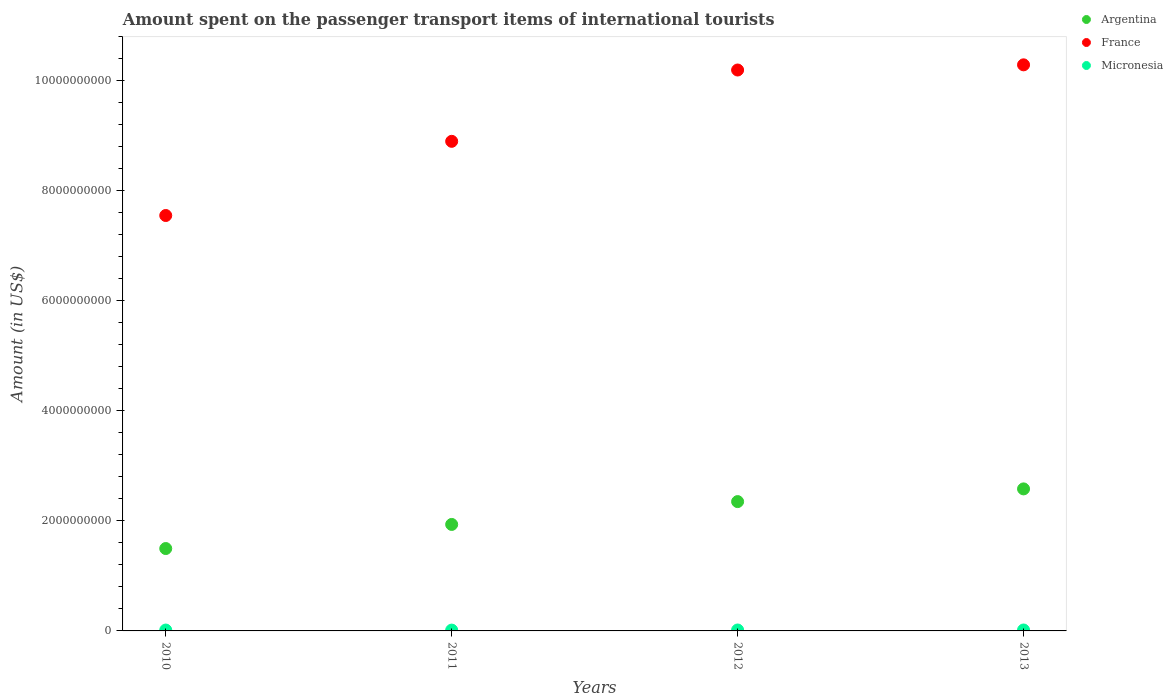What is the amount spent on the passenger transport items of international tourists in Micronesia in 2012?
Offer a terse response. 1.70e+07. Across all years, what is the maximum amount spent on the passenger transport items of international tourists in Micronesia?
Offer a very short reply. 1.70e+07. Across all years, what is the minimum amount spent on the passenger transport items of international tourists in France?
Your answer should be compact. 7.55e+09. In which year was the amount spent on the passenger transport items of international tourists in France maximum?
Provide a short and direct response. 2013. In which year was the amount spent on the passenger transport items of international tourists in France minimum?
Ensure brevity in your answer.  2010. What is the total amount spent on the passenger transport items of international tourists in France in the graph?
Offer a terse response. 3.69e+1. What is the difference between the amount spent on the passenger transport items of international tourists in France in 2013 and the amount spent on the passenger transport items of international tourists in Micronesia in 2012?
Offer a very short reply. 1.03e+1. What is the average amount spent on the passenger transport items of international tourists in France per year?
Provide a short and direct response. 9.23e+09. In the year 2012, what is the difference between the amount spent on the passenger transport items of international tourists in Micronesia and amount spent on the passenger transport items of international tourists in Argentina?
Provide a short and direct response. -2.33e+09. In how many years, is the amount spent on the passenger transport items of international tourists in Argentina greater than 3200000000 US$?
Provide a succinct answer. 0. What is the ratio of the amount spent on the passenger transport items of international tourists in France in 2010 to that in 2013?
Your answer should be very brief. 0.73. Is the difference between the amount spent on the passenger transport items of international tourists in Micronesia in 2010 and 2012 greater than the difference between the amount spent on the passenger transport items of international tourists in Argentina in 2010 and 2012?
Keep it short and to the point. Yes. What is the difference between the highest and the lowest amount spent on the passenger transport items of international tourists in Argentina?
Provide a short and direct response. 1.08e+09. Is it the case that in every year, the sum of the amount spent on the passenger transport items of international tourists in Argentina and amount spent on the passenger transport items of international tourists in Micronesia  is greater than the amount spent on the passenger transport items of international tourists in France?
Your answer should be compact. No. Is the amount spent on the passenger transport items of international tourists in Argentina strictly less than the amount spent on the passenger transport items of international tourists in Micronesia over the years?
Provide a short and direct response. No. How many years are there in the graph?
Ensure brevity in your answer.  4. What is the difference between two consecutive major ticks on the Y-axis?
Provide a short and direct response. 2.00e+09. Does the graph contain grids?
Ensure brevity in your answer.  No. Where does the legend appear in the graph?
Ensure brevity in your answer.  Top right. What is the title of the graph?
Your answer should be compact. Amount spent on the passenger transport items of international tourists. What is the label or title of the X-axis?
Provide a succinct answer. Years. What is the Amount (in US$) in Argentina in 2010?
Offer a terse response. 1.50e+09. What is the Amount (in US$) in France in 2010?
Your answer should be very brief. 7.55e+09. What is the Amount (in US$) of Micronesia in 2010?
Offer a terse response. 1.60e+07. What is the Amount (in US$) in Argentina in 2011?
Make the answer very short. 1.94e+09. What is the Amount (in US$) of France in 2011?
Offer a terse response. 8.90e+09. What is the Amount (in US$) in Micronesia in 2011?
Your answer should be very brief. 1.50e+07. What is the Amount (in US$) in Argentina in 2012?
Your answer should be compact. 2.35e+09. What is the Amount (in US$) in France in 2012?
Make the answer very short. 1.02e+1. What is the Amount (in US$) in Micronesia in 2012?
Provide a succinct answer. 1.70e+07. What is the Amount (in US$) in Argentina in 2013?
Your response must be concise. 2.58e+09. What is the Amount (in US$) in France in 2013?
Ensure brevity in your answer.  1.03e+1. What is the Amount (in US$) of Micronesia in 2013?
Give a very brief answer. 1.70e+07. Across all years, what is the maximum Amount (in US$) of Argentina?
Keep it short and to the point. 2.58e+09. Across all years, what is the maximum Amount (in US$) of France?
Ensure brevity in your answer.  1.03e+1. Across all years, what is the maximum Amount (in US$) of Micronesia?
Your answer should be very brief. 1.70e+07. Across all years, what is the minimum Amount (in US$) in Argentina?
Ensure brevity in your answer.  1.50e+09. Across all years, what is the minimum Amount (in US$) of France?
Your answer should be very brief. 7.55e+09. Across all years, what is the minimum Amount (in US$) of Micronesia?
Your response must be concise. 1.50e+07. What is the total Amount (in US$) of Argentina in the graph?
Make the answer very short. 8.36e+09. What is the total Amount (in US$) of France in the graph?
Give a very brief answer. 3.69e+1. What is the total Amount (in US$) in Micronesia in the graph?
Your response must be concise. 6.50e+07. What is the difference between the Amount (in US$) in Argentina in 2010 and that in 2011?
Ensure brevity in your answer.  -4.38e+08. What is the difference between the Amount (in US$) of France in 2010 and that in 2011?
Provide a short and direct response. -1.35e+09. What is the difference between the Amount (in US$) of Micronesia in 2010 and that in 2011?
Offer a very short reply. 1.00e+06. What is the difference between the Amount (in US$) in Argentina in 2010 and that in 2012?
Your answer should be very brief. -8.53e+08. What is the difference between the Amount (in US$) of France in 2010 and that in 2012?
Your answer should be compact. -2.64e+09. What is the difference between the Amount (in US$) of Argentina in 2010 and that in 2013?
Give a very brief answer. -1.08e+09. What is the difference between the Amount (in US$) of France in 2010 and that in 2013?
Offer a terse response. -2.74e+09. What is the difference between the Amount (in US$) in Micronesia in 2010 and that in 2013?
Keep it short and to the point. -1.00e+06. What is the difference between the Amount (in US$) in Argentina in 2011 and that in 2012?
Your answer should be very brief. -4.15e+08. What is the difference between the Amount (in US$) in France in 2011 and that in 2012?
Your answer should be compact. -1.30e+09. What is the difference between the Amount (in US$) of Micronesia in 2011 and that in 2012?
Give a very brief answer. -2.00e+06. What is the difference between the Amount (in US$) of Argentina in 2011 and that in 2013?
Offer a very short reply. -6.46e+08. What is the difference between the Amount (in US$) of France in 2011 and that in 2013?
Provide a succinct answer. -1.39e+09. What is the difference between the Amount (in US$) of Argentina in 2012 and that in 2013?
Ensure brevity in your answer.  -2.31e+08. What is the difference between the Amount (in US$) in France in 2012 and that in 2013?
Provide a short and direct response. -9.40e+07. What is the difference between the Amount (in US$) in Micronesia in 2012 and that in 2013?
Offer a terse response. 0. What is the difference between the Amount (in US$) of Argentina in 2010 and the Amount (in US$) of France in 2011?
Offer a very short reply. -7.40e+09. What is the difference between the Amount (in US$) of Argentina in 2010 and the Amount (in US$) of Micronesia in 2011?
Provide a succinct answer. 1.48e+09. What is the difference between the Amount (in US$) in France in 2010 and the Amount (in US$) in Micronesia in 2011?
Provide a short and direct response. 7.53e+09. What is the difference between the Amount (in US$) of Argentina in 2010 and the Amount (in US$) of France in 2012?
Give a very brief answer. -8.70e+09. What is the difference between the Amount (in US$) of Argentina in 2010 and the Amount (in US$) of Micronesia in 2012?
Provide a short and direct response. 1.48e+09. What is the difference between the Amount (in US$) in France in 2010 and the Amount (in US$) in Micronesia in 2012?
Provide a succinct answer. 7.53e+09. What is the difference between the Amount (in US$) of Argentina in 2010 and the Amount (in US$) of France in 2013?
Offer a terse response. -8.79e+09. What is the difference between the Amount (in US$) in Argentina in 2010 and the Amount (in US$) in Micronesia in 2013?
Your answer should be very brief. 1.48e+09. What is the difference between the Amount (in US$) in France in 2010 and the Amount (in US$) in Micronesia in 2013?
Provide a short and direct response. 7.53e+09. What is the difference between the Amount (in US$) of Argentina in 2011 and the Amount (in US$) of France in 2012?
Offer a very short reply. -8.26e+09. What is the difference between the Amount (in US$) in Argentina in 2011 and the Amount (in US$) in Micronesia in 2012?
Your answer should be very brief. 1.92e+09. What is the difference between the Amount (in US$) of France in 2011 and the Amount (in US$) of Micronesia in 2012?
Give a very brief answer. 8.88e+09. What is the difference between the Amount (in US$) in Argentina in 2011 and the Amount (in US$) in France in 2013?
Your answer should be compact. -8.35e+09. What is the difference between the Amount (in US$) in Argentina in 2011 and the Amount (in US$) in Micronesia in 2013?
Your response must be concise. 1.92e+09. What is the difference between the Amount (in US$) in France in 2011 and the Amount (in US$) in Micronesia in 2013?
Provide a short and direct response. 8.88e+09. What is the difference between the Amount (in US$) in Argentina in 2012 and the Amount (in US$) in France in 2013?
Make the answer very short. -7.94e+09. What is the difference between the Amount (in US$) of Argentina in 2012 and the Amount (in US$) of Micronesia in 2013?
Make the answer very short. 2.33e+09. What is the difference between the Amount (in US$) of France in 2012 and the Amount (in US$) of Micronesia in 2013?
Your answer should be compact. 1.02e+1. What is the average Amount (in US$) of Argentina per year?
Give a very brief answer. 2.09e+09. What is the average Amount (in US$) of France per year?
Your answer should be very brief. 9.23e+09. What is the average Amount (in US$) of Micronesia per year?
Offer a terse response. 1.62e+07. In the year 2010, what is the difference between the Amount (in US$) in Argentina and Amount (in US$) in France?
Offer a very short reply. -6.05e+09. In the year 2010, what is the difference between the Amount (in US$) of Argentina and Amount (in US$) of Micronesia?
Offer a terse response. 1.48e+09. In the year 2010, what is the difference between the Amount (in US$) of France and Amount (in US$) of Micronesia?
Offer a terse response. 7.53e+09. In the year 2011, what is the difference between the Amount (in US$) of Argentina and Amount (in US$) of France?
Offer a very short reply. -6.96e+09. In the year 2011, what is the difference between the Amount (in US$) in Argentina and Amount (in US$) in Micronesia?
Your response must be concise. 1.92e+09. In the year 2011, what is the difference between the Amount (in US$) in France and Amount (in US$) in Micronesia?
Provide a short and direct response. 8.88e+09. In the year 2012, what is the difference between the Amount (in US$) of Argentina and Amount (in US$) of France?
Your answer should be very brief. -7.84e+09. In the year 2012, what is the difference between the Amount (in US$) of Argentina and Amount (in US$) of Micronesia?
Ensure brevity in your answer.  2.33e+09. In the year 2012, what is the difference between the Amount (in US$) in France and Amount (in US$) in Micronesia?
Your answer should be compact. 1.02e+1. In the year 2013, what is the difference between the Amount (in US$) in Argentina and Amount (in US$) in France?
Provide a short and direct response. -7.71e+09. In the year 2013, what is the difference between the Amount (in US$) of Argentina and Amount (in US$) of Micronesia?
Keep it short and to the point. 2.56e+09. In the year 2013, what is the difference between the Amount (in US$) of France and Amount (in US$) of Micronesia?
Give a very brief answer. 1.03e+1. What is the ratio of the Amount (in US$) of Argentina in 2010 to that in 2011?
Keep it short and to the point. 0.77. What is the ratio of the Amount (in US$) in France in 2010 to that in 2011?
Give a very brief answer. 0.85. What is the ratio of the Amount (in US$) of Micronesia in 2010 to that in 2011?
Your answer should be very brief. 1.07. What is the ratio of the Amount (in US$) in Argentina in 2010 to that in 2012?
Provide a short and direct response. 0.64. What is the ratio of the Amount (in US$) of France in 2010 to that in 2012?
Your answer should be very brief. 0.74. What is the ratio of the Amount (in US$) of Micronesia in 2010 to that in 2012?
Offer a terse response. 0.94. What is the ratio of the Amount (in US$) of Argentina in 2010 to that in 2013?
Give a very brief answer. 0.58. What is the ratio of the Amount (in US$) of France in 2010 to that in 2013?
Provide a succinct answer. 0.73. What is the ratio of the Amount (in US$) in Micronesia in 2010 to that in 2013?
Your answer should be compact. 0.94. What is the ratio of the Amount (in US$) in Argentina in 2011 to that in 2012?
Your answer should be compact. 0.82. What is the ratio of the Amount (in US$) in France in 2011 to that in 2012?
Keep it short and to the point. 0.87. What is the ratio of the Amount (in US$) of Micronesia in 2011 to that in 2012?
Your answer should be compact. 0.88. What is the ratio of the Amount (in US$) in Argentina in 2011 to that in 2013?
Keep it short and to the point. 0.75. What is the ratio of the Amount (in US$) of France in 2011 to that in 2013?
Your answer should be very brief. 0.86. What is the ratio of the Amount (in US$) in Micronesia in 2011 to that in 2013?
Keep it short and to the point. 0.88. What is the ratio of the Amount (in US$) of Argentina in 2012 to that in 2013?
Ensure brevity in your answer.  0.91. What is the ratio of the Amount (in US$) in France in 2012 to that in 2013?
Offer a terse response. 0.99. What is the ratio of the Amount (in US$) of Micronesia in 2012 to that in 2013?
Keep it short and to the point. 1. What is the difference between the highest and the second highest Amount (in US$) in Argentina?
Your response must be concise. 2.31e+08. What is the difference between the highest and the second highest Amount (in US$) in France?
Offer a terse response. 9.40e+07. What is the difference between the highest and the second highest Amount (in US$) in Micronesia?
Offer a very short reply. 0. What is the difference between the highest and the lowest Amount (in US$) in Argentina?
Provide a succinct answer. 1.08e+09. What is the difference between the highest and the lowest Amount (in US$) in France?
Your response must be concise. 2.74e+09. What is the difference between the highest and the lowest Amount (in US$) of Micronesia?
Offer a terse response. 2.00e+06. 